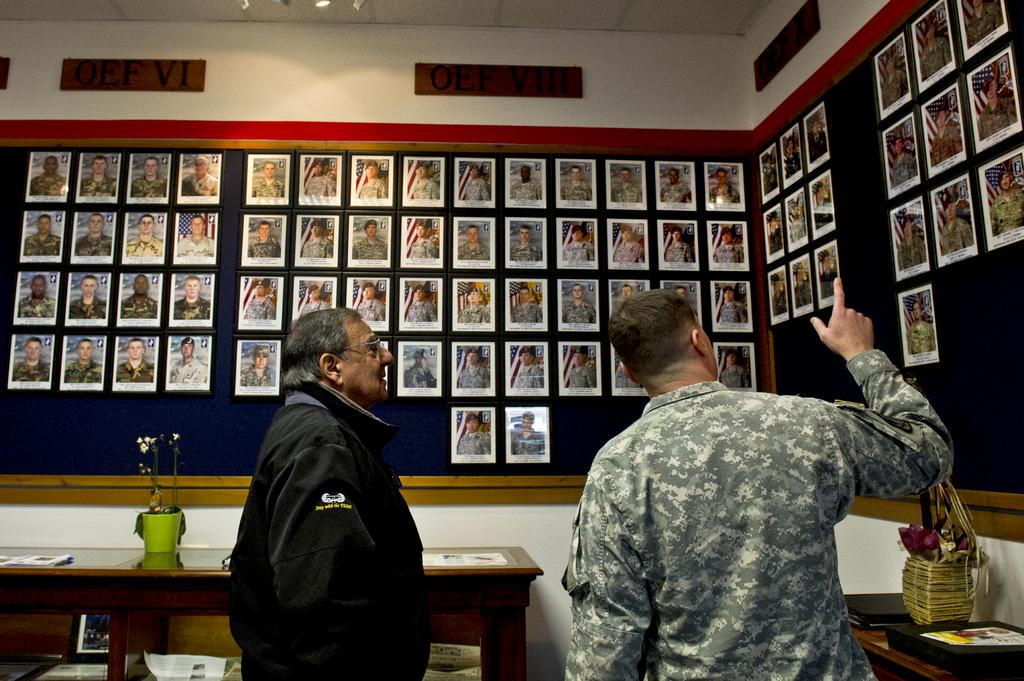What are the two men in the image doing? The two men in the image are standing and talking. What are they talking about? They are discussing a photograph on the wall. What can be seen in the background of the image? There is a table in the background of the image. What is on the table in the background? There is a pot on the table in the background. What type of ground can be seen beneath the men in the image? There is no information about the ground beneath the men in the image; it is not visible. 